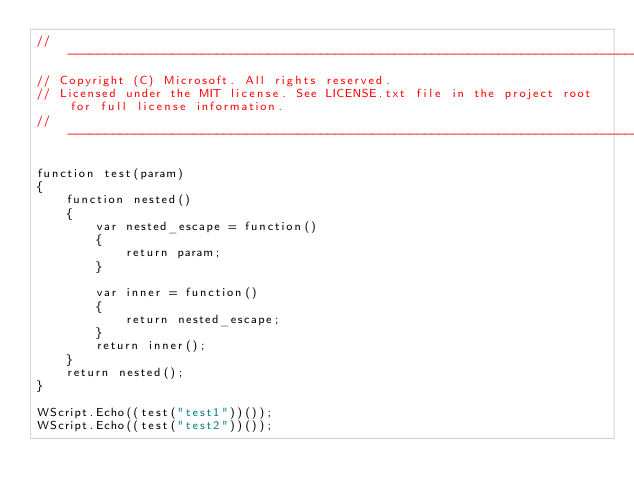<code> <loc_0><loc_0><loc_500><loc_500><_JavaScript_>//-------------------------------------------------------------------------------------------------------
// Copyright (C) Microsoft. All rights reserved.
// Licensed under the MIT license. See LICENSE.txt file in the project root for full license information.
//-------------------------------------------------------------------------------------------------------

function test(param)
{
    function nested()
    {
        var nested_escape = function()
        {
            return param;
        }

        var inner = function()
        {
            return nested_escape;
        }
        return inner();
    }
    return nested();
}

WScript.Echo((test("test1"))());
WScript.Echo((test("test2"))());
</code> 